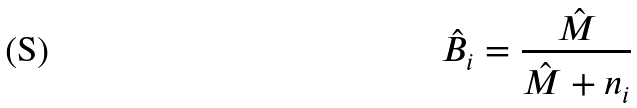Convert formula to latex. <formula><loc_0><loc_0><loc_500><loc_500>\hat { B _ { i } } = \frac { \hat { M } } { \hat { M } + n _ { i } }</formula> 